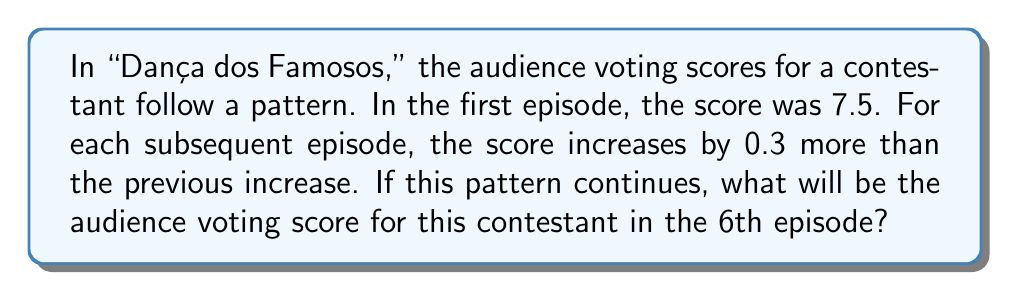Give your solution to this math problem. Let's break this down step-by-step:

1) First, let's identify the pattern of increases:
   Episode 1 to 2: 0.3 increase
   Episode 2 to 3: 0.6 increase (0.3 + 0.3)
   Episode 3 to 4: 0.9 increase (0.6 + 0.3)
   Episode 4 to 5: 1.2 increase (0.9 + 0.3)
   Episode 5 to 6: 1.5 increase (1.2 + 0.3)

2) Now, let's calculate the scores for each episode:
   Episode 1: 7.5
   Episode 2: $7.5 + 0.3 = 7.8$
   Episode 3: $7.8 + 0.6 = 8.4$
   Episode 4: $8.4 + 0.9 = 9.3$
   Episode 5: $9.3 + 1.2 = 10.5$
   Episode 6: $10.5 + 1.5 = 12$

3) We can verify this using the arithmetic sequence formula:
   $a_n = a_1 + \frac{n(n-1)}{2}d$
   Where $a_1 = 7.5$, $n = 6$, and $d = 0.3$

   $a_6 = 7.5 + \frac{6(6-1)}{2}(0.3) = 7.5 + 4.5 = 12$

Therefore, the audience voting score for the contestant in the 6th episode will be 12.
Answer: 12 